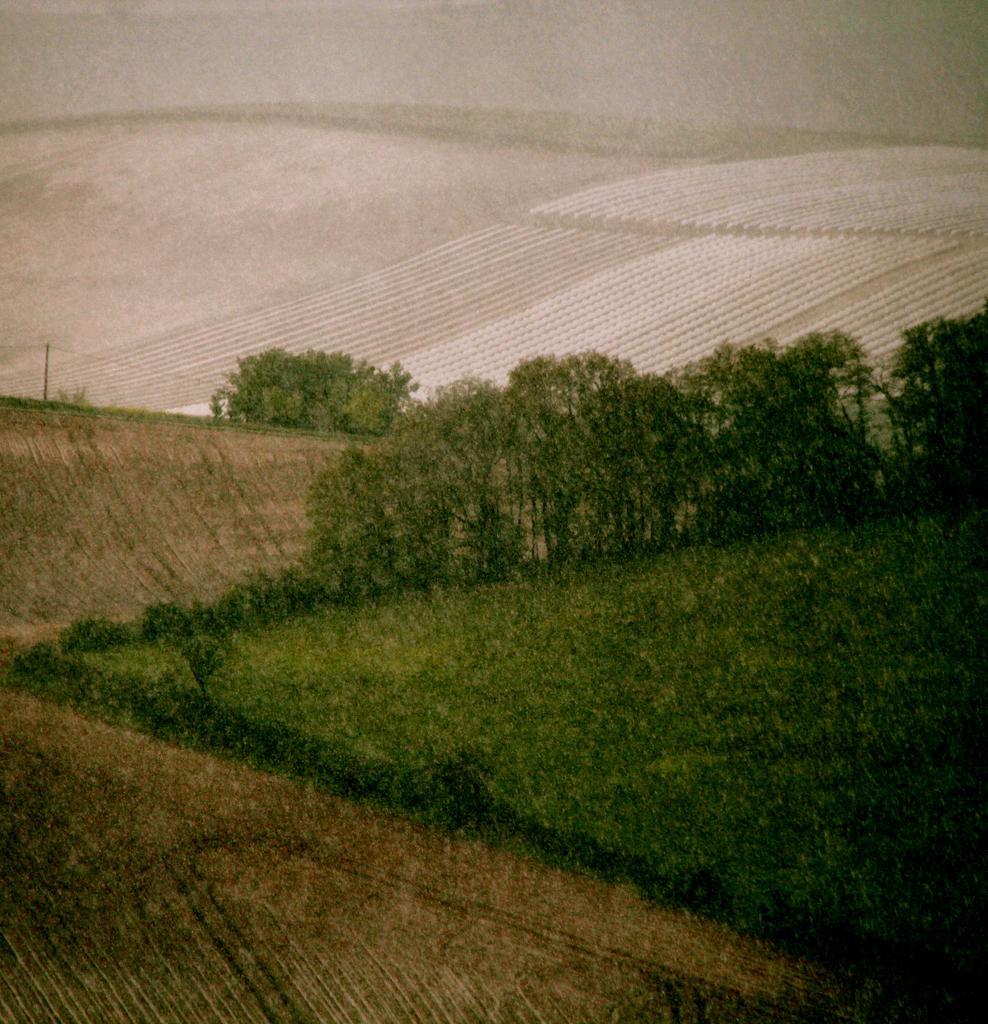Please provide a concise description of this image. In the image we can see some trees and grass. 